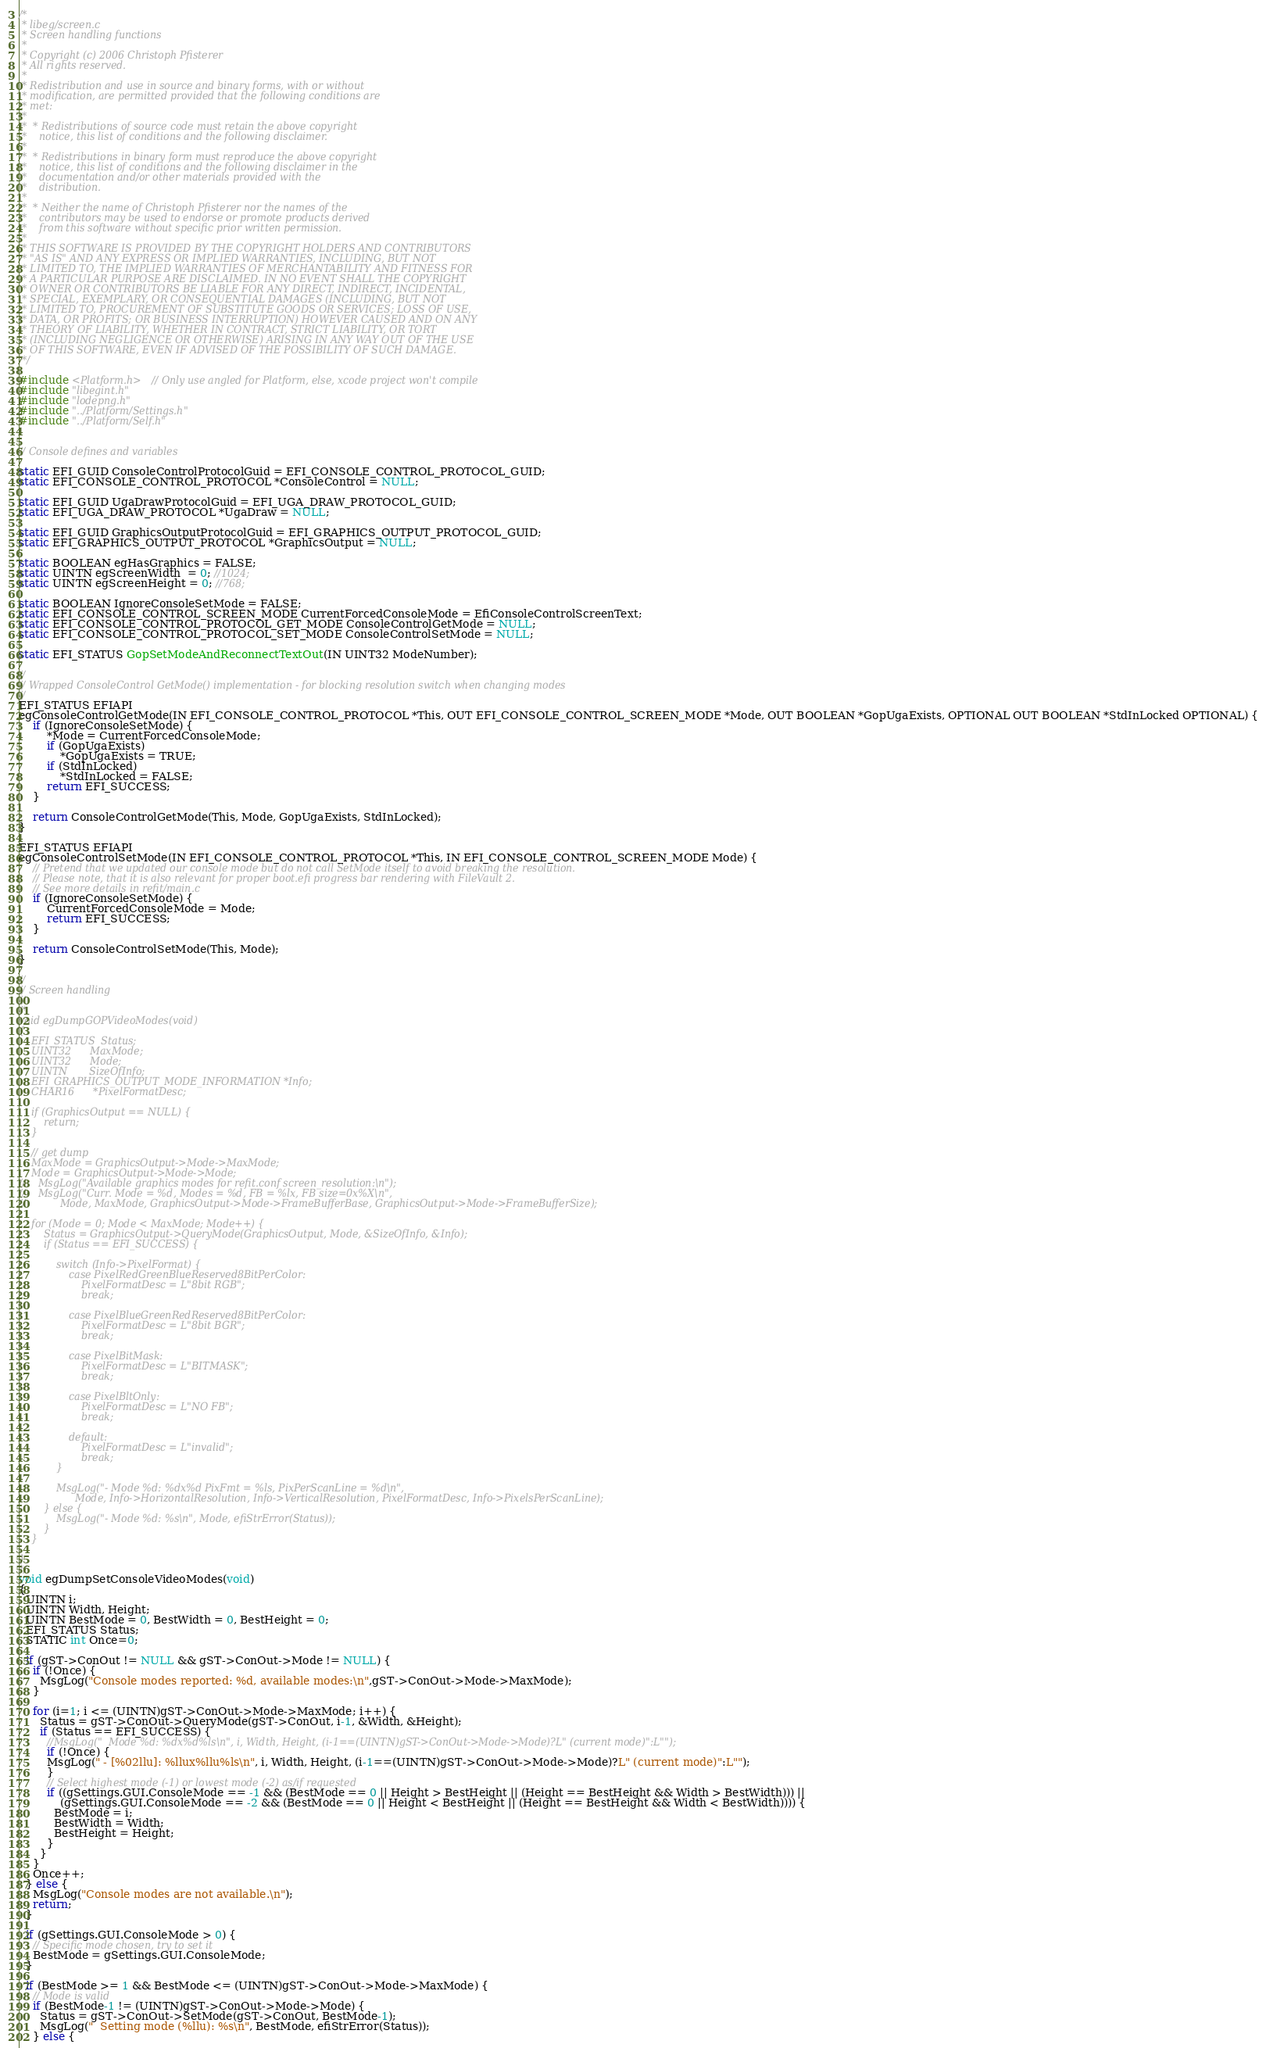Convert code to text. <code><loc_0><loc_0><loc_500><loc_500><_C++_>/*
 * libeg/screen.c
 * Screen handling functions
 *
 * Copyright (c) 2006 Christoph Pfisterer
 * All rights reserved.
 *
 * Redistribution and use in source and binary forms, with or without
 * modification, are permitted provided that the following conditions are
 * met:
 *
 *  * Redistributions of source code must retain the above copyright
 *    notice, this list of conditions and the following disclaimer.
 *
 *  * Redistributions in binary form must reproduce the above copyright
 *    notice, this list of conditions and the following disclaimer in the
 *    documentation and/or other materials provided with the
 *    distribution.
 *
 *  * Neither the name of Christoph Pfisterer nor the names of the
 *    contributors may be used to endorse or promote products derived
 *    from this software without specific prior written permission.
 *
 * THIS SOFTWARE IS PROVIDED BY THE COPYRIGHT HOLDERS AND CONTRIBUTORS
 * "AS IS" AND ANY EXPRESS OR IMPLIED WARRANTIES, INCLUDING, BUT NOT
 * LIMITED TO, THE IMPLIED WARRANTIES OF MERCHANTABILITY AND FITNESS FOR
 * A PARTICULAR PURPOSE ARE DISCLAIMED. IN NO EVENT SHALL THE COPYRIGHT
 * OWNER OR CONTRIBUTORS BE LIABLE FOR ANY DIRECT, INDIRECT, INCIDENTAL,
 * SPECIAL, EXEMPLARY, OR CONSEQUENTIAL DAMAGES (INCLUDING, BUT NOT
 * LIMITED TO, PROCUREMENT OF SUBSTITUTE GOODS OR SERVICES; LOSS OF USE,
 * DATA, OR PROFITS; OR BUSINESS INTERRUPTION) HOWEVER CAUSED AND ON ANY
 * THEORY OF LIABILITY, WHETHER IN CONTRACT, STRICT LIABILITY, OR TORT
 * (INCLUDING NEGLIGENCE OR OTHERWISE) ARISING IN ANY WAY OUT OF THE USE
 * OF THIS SOFTWARE, EVEN IF ADVISED OF THE POSSIBILITY OF SUCH DAMAGE.
 */

#include <Platform.h> // Only use angled for Platform, else, xcode project won't compile
#include "libegint.h"
#include "lodepng.h"
#include "../Platform/Settings.h"
#include "../Platform/Self.h"


// Console defines and variables

static EFI_GUID ConsoleControlProtocolGuid = EFI_CONSOLE_CONTROL_PROTOCOL_GUID;
static EFI_CONSOLE_CONTROL_PROTOCOL *ConsoleControl = NULL;

static EFI_GUID UgaDrawProtocolGuid = EFI_UGA_DRAW_PROTOCOL_GUID;
static EFI_UGA_DRAW_PROTOCOL *UgaDraw = NULL;

static EFI_GUID GraphicsOutputProtocolGuid = EFI_GRAPHICS_OUTPUT_PROTOCOL_GUID;
static EFI_GRAPHICS_OUTPUT_PROTOCOL *GraphicsOutput = NULL;

static BOOLEAN egHasGraphics = FALSE;
static UINTN egScreenWidth  = 0; //1024;
static UINTN egScreenHeight = 0; //768;

static BOOLEAN IgnoreConsoleSetMode = FALSE;
static EFI_CONSOLE_CONTROL_SCREEN_MODE CurrentForcedConsoleMode = EfiConsoleControlScreenText;
static EFI_CONSOLE_CONTROL_PROTOCOL_GET_MODE ConsoleControlGetMode = NULL;
static EFI_CONSOLE_CONTROL_PROTOCOL_SET_MODE ConsoleControlSetMode = NULL;

static EFI_STATUS GopSetModeAndReconnectTextOut(IN UINT32 ModeNumber);

//
// Wrapped ConsoleControl GetMode() implementation - for blocking resolution switch when changing modes
//
EFI_STATUS EFIAPI
egConsoleControlGetMode(IN EFI_CONSOLE_CONTROL_PROTOCOL *This, OUT EFI_CONSOLE_CONTROL_SCREEN_MODE *Mode, OUT BOOLEAN *GopUgaExists, OPTIONAL OUT BOOLEAN *StdInLocked OPTIONAL) {
    if (IgnoreConsoleSetMode) {
        *Mode = CurrentForcedConsoleMode;
        if (GopUgaExists)
            *GopUgaExists = TRUE;
        if (StdInLocked)
            *StdInLocked = FALSE;
        return EFI_SUCCESS;
    }

    return ConsoleControlGetMode(This, Mode, GopUgaExists, StdInLocked);
}

EFI_STATUS EFIAPI
egConsoleControlSetMode(IN EFI_CONSOLE_CONTROL_PROTOCOL *This, IN EFI_CONSOLE_CONTROL_SCREEN_MODE Mode) {
    // Pretend that we updated our console mode but do not call SetMode itself to avoid breaking the resolution.
    // Please note, that it is also relevant for proper boot.efi progress bar rendering with FileVault 2.
    // See more details in refit/main.c
    if (IgnoreConsoleSetMode) {
        CurrentForcedConsoleMode = Mode;
        return EFI_SUCCESS;
    }

    return ConsoleControlSetMode(This, Mode);
}

//
// Screen handling
//
/*
void egDumpGOPVideoModes(void)
{
    EFI_STATUS  Status;
    UINT32      MaxMode;
    UINT32      Mode;
    UINTN       SizeOfInfo;
    EFI_GRAPHICS_OUTPUT_MODE_INFORMATION *Info;
    CHAR16      *PixelFormatDesc;
    
    if (GraphicsOutput == NULL) {
        return;
    }
    
    // get dump
    MaxMode = GraphicsOutput->Mode->MaxMode;
    Mode = GraphicsOutput->Mode->Mode;
//    MsgLog("Available graphics modes for refit.conf screen_resolution:\n");
//    MsgLog("Curr. Mode = %d, Modes = %d, FB = %lx, FB size=0x%X\n",
//           Mode, MaxMode, GraphicsOutput->Mode->FrameBufferBase, GraphicsOutput->Mode->FrameBufferSize);
    
    for (Mode = 0; Mode < MaxMode; Mode++) {
        Status = GraphicsOutput->QueryMode(GraphicsOutput, Mode, &SizeOfInfo, &Info);
        if (Status == EFI_SUCCESS) {
            
            switch (Info->PixelFormat) {
                case PixelRedGreenBlueReserved8BitPerColor:
                    PixelFormatDesc = L"8bit RGB";
                    break;
                    
                case PixelBlueGreenRedReserved8BitPerColor:
                    PixelFormatDesc = L"8bit BGR";
                    break;
                    
                case PixelBitMask:
                    PixelFormatDesc = L"BITMASK";
                    break;
                    
                case PixelBltOnly:
                    PixelFormatDesc = L"NO FB";
                    break;
                    
                default:
                    PixelFormatDesc = L"invalid";
                    break;
            }
            
            MsgLog("- Mode %d: %dx%d PixFmt = %ls, PixPerScanLine = %d\n",
                  Mode, Info->HorizontalResolution, Info->VerticalResolution, PixelFormatDesc, Info->PixelsPerScanLine);
        } else {
            MsgLog("- Mode %d: %s\n", Mode, efiStrError(Status));
        }
    }
    
}
*/
void egDumpSetConsoleVideoModes(void)
{
  UINTN i;
  UINTN Width, Height;
  UINTN BestMode = 0, BestWidth = 0, BestHeight = 0;
  EFI_STATUS Status;
  STATIC int Once=0;
  
  if (gST->ConOut != NULL && gST->ConOut->Mode != NULL) {
    if (!Once) {
      MsgLog("Console modes reported: %d, available modes:\n",gST->ConOut->Mode->MaxMode);
    }
    
    for (i=1; i <= (UINTN)gST->ConOut->Mode->MaxMode; i++) {
      Status = gST->ConOut->QueryMode(gST->ConOut, i-1, &Width, &Height);
      if (Status == EFI_SUCCESS) {
        //MsgLog("  Mode %d: %dx%d%ls\n", i, Width, Height, (i-1==(UINTN)gST->ConOut->Mode->Mode)?L" (current mode)":L"");
        if (!Once) {
        MsgLog(" - [%02llu]: %llux%llu%ls\n", i, Width, Height, (i-1==(UINTN)gST->ConOut->Mode->Mode)?L" (current mode)":L"");
        }
        // Select highest mode (-1) or lowest mode (-2) as/if requested
        if ((gSettings.GUI.ConsoleMode == -1 && (BestMode == 0 || Height > BestHeight || (Height == BestHeight && Width > BestWidth))) ||
            (gSettings.GUI.ConsoleMode == -2 && (BestMode == 0 || Height < BestHeight || (Height == BestHeight && Width < BestWidth)))) {
          BestMode = i;
          BestWidth = Width;
          BestHeight = Height;
        }
      }
    }
    Once++;
  } else {
    MsgLog("Console modes are not available.\n");
    return;
  }
  
  if (gSettings.GUI.ConsoleMode > 0) {
    // Specific mode chosen, try to set it
    BestMode = gSettings.GUI.ConsoleMode;
  }
  
  if (BestMode >= 1 && BestMode <= (UINTN)gST->ConOut->Mode->MaxMode) {
    // Mode is valid
    if (BestMode-1 != (UINTN)gST->ConOut->Mode->Mode) {
      Status = gST->ConOut->SetMode(gST->ConOut, BestMode-1);
      MsgLog("  Setting mode (%llu): %s\n", BestMode, efiStrError(Status));
    } else {</code> 